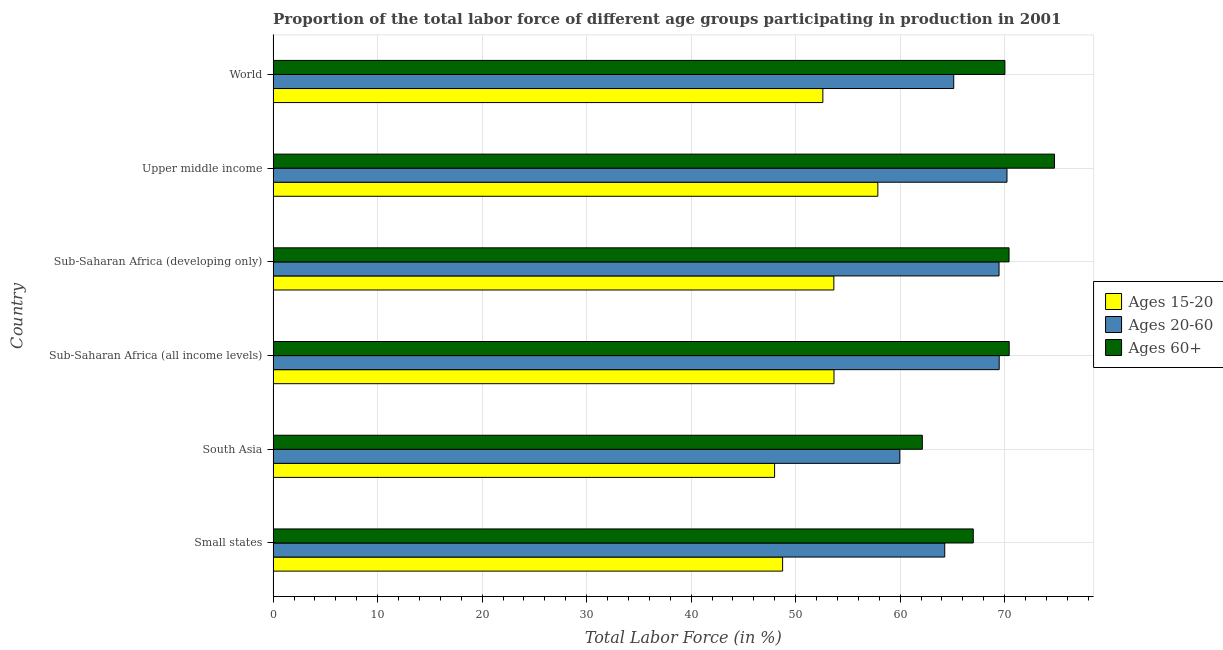How many different coloured bars are there?
Make the answer very short. 3. Are the number of bars per tick equal to the number of legend labels?
Ensure brevity in your answer.  Yes. What is the label of the 3rd group of bars from the top?
Offer a terse response. Sub-Saharan Africa (developing only). In how many cases, is the number of bars for a given country not equal to the number of legend labels?
Provide a succinct answer. 0. What is the percentage of labor force within the age group 20-60 in South Asia?
Give a very brief answer. 59.97. Across all countries, what is the maximum percentage of labor force within the age group 20-60?
Give a very brief answer. 70.22. Across all countries, what is the minimum percentage of labor force within the age group 20-60?
Offer a very short reply. 59.97. In which country was the percentage of labor force within the age group 20-60 maximum?
Your answer should be very brief. Upper middle income. In which country was the percentage of labor force within the age group 15-20 minimum?
Ensure brevity in your answer.  South Asia. What is the total percentage of labor force within the age group 15-20 in the graph?
Make the answer very short. 314.54. What is the difference between the percentage of labor force within the age group 15-20 in Small states and that in World?
Offer a terse response. -3.85. What is the difference between the percentage of labor force within the age group 15-20 in World and the percentage of labor force above age 60 in Sub-Saharan Africa (developing only)?
Provide a short and direct response. -17.82. What is the average percentage of labor force within the age group 15-20 per country?
Your answer should be very brief. 52.42. What is the difference between the percentage of labor force above age 60 and percentage of labor force within the age group 20-60 in Small states?
Your answer should be very brief. 2.73. What is the ratio of the percentage of labor force within the age group 15-20 in Upper middle income to that in World?
Provide a succinct answer. 1.1. Is the percentage of labor force above age 60 in South Asia less than that in Upper middle income?
Give a very brief answer. Yes. What is the difference between the highest and the second highest percentage of labor force within the age group 20-60?
Offer a terse response. 0.74. What is the difference between the highest and the lowest percentage of labor force within the age group 20-60?
Keep it short and to the point. 10.25. In how many countries, is the percentage of labor force within the age group 20-60 greater than the average percentage of labor force within the age group 20-60 taken over all countries?
Your answer should be compact. 3. What does the 2nd bar from the top in South Asia represents?
Provide a succinct answer. Ages 20-60. What does the 2nd bar from the bottom in South Asia represents?
Provide a succinct answer. Ages 20-60. How many bars are there?
Your response must be concise. 18. How many countries are there in the graph?
Provide a short and direct response. 6. What is the difference between two consecutive major ticks on the X-axis?
Your response must be concise. 10. Are the values on the major ticks of X-axis written in scientific E-notation?
Give a very brief answer. No. Does the graph contain any zero values?
Make the answer very short. No. Where does the legend appear in the graph?
Ensure brevity in your answer.  Center right. How many legend labels are there?
Give a very brief answer. 3. How are the legend labels stacked?
Keep it short and to the point. Vertical. What is the title of the graph?
Provide a short and direct response. Proportion of the total labor force of different age groups participating in production in 2001. Does "Primary" appear as one of the legend labels in the graph?
Ensure brevity in your answer.  No. What is the label or title of the X-axis?
Your answer should be very brief. Total Labor Force (in %). What is the label or title of the Y-axis?
Keep it short and to the point. Country. What is the Total Labor Force (in %) of Ages 15-20 in Small states?
Offer a terse response. 48.75. What is the Total Labor Force (in %) in Ages 20-60 in Small states?
Offer a terse response. 64.27. What is the Total Labor Force (in %) in Ages 60+ in Small states?
Your answer should be very brief. 67. What is the Total Labor Force (in %) in Ages 15-20 in South Asia?
Give a very brief answer. 47.99. What is the Total Labor Force (in %) of Ages 20-60 in South Asia?
Keep it short and to the point. 59.97. What is the Total Labor Force (in %) of Ages 60+ in South Asia?
Provide a short and direct response. 62.12. What is the Total Labor Force (in %) of Ages 15-20 in Sub-Saharan Africa (all income levels)?
Provide a succinct answer. 53.67. What is the Total Labor Force (in %) in Ages 20-60 in Sub-Saharan Africa (all income levels)?
Provide a short and direct response. 69.48. What is the Total Labor Force (in %) in Ages 60+ in Sub-Saharan Africa (all income levels)?
Give a very brief answer. 70.44. What is the Total Labor Force (in %) of Ages 15-20 in Sub-Saharan Africa (developing only)?
Ensure brevity in your answer.  53.66. What is the Total Labor Force (in %) of Ages 20-60 in Sub-Saharan Africa (developing only)?
Your answer should be very brief. 69.46. What is the Total Labor Force (in %) in Ages 60+ in Sub-Saharan Africa (developing only)?
Ensure brevity in your answer.  70.42. What is the Total Labor Force (in %) in Ages 15-20 in Upper middle income?
Provide a short and direct response. 57.87. What is the Total Labor Force (in %) in Ages 20-60 in Upper middle income?
Keep it short and to the point. 70.22. What is the Total Labor Force (in %) in Ages 60+ in Upper middle income?
Your answer should be compact. 74.77. What is the Total Labor Force (in %) in Ages 15-20 in World?
Offer a very short reply. 52.6. What is the Total Labor Force (in %) of Ages 20-60 in World?
Make the answer very short. 65.13. What is the Total Labor Force (in %) in Ages 60+ in World?
Your answer should be compact. 70.02. Across all countries, what is the maximum Total Labor Force (in %) in Ages 15-20?
Keep it short and to the point. 57.87. Across all countries, what is the maximum Total Labor Force (in %) in Ages 20-60?
Provide a succinct answer. 70.22. Across all countries, what is the maximum Total Labor Force (in %) in Ages 60+?
Keep it short and to the point. 74.77. Across all countries, what is the minimum Total Labor Force (in %) of Ages 15-20?
Give a very brief answer. 47.99. Across all countries, what is the minimum Total Labor Force (in %) of Ages 20-60?
Provide a succinct answer. 59.97. Across all countries, what is the minimum Total Labor Force (in %) of Ages 60+?
Keep it short and to the point. 62.12. What is the total Total Labor Force (in %) in Ages 15-20 in the graph?
Offer a very short reply. 314.54. What is the total Total Labor Force (in %) in Ages 20-60 in the graph?
Give a very brief answer. 398.53. What is the total Total Labor Force (in %) in Ages 60+ in the graph?
Keep it short and to the point. 414.77. What is the difference between the Total Labor Force (in %) of Ages 15-20 in Small states and that in South Asia?
Your answer should be compact. 0.77. What is the difference between the Total Labor Force (in %) of Ages 20-60 in Small states and that in South Asia?
Provide a succinct answer. 4.3. What is the difference between the Total Labor Force (in %) of Ages 60+ in Small states and that in South Asia?
Ensure brevity in your answer.  4.88. What is the difference between the Total Labor Force (in %) of Ages 15-20 in Small states and that in Sub-Saharan Africa (all income levels)?
Your answer should be compact. -4.92. What is the difference between the Total Labor Force (in %) of Ages 20-60 in Small states and that in Sub-Saharan Africa (all income levels)?
Your answer should be compact. -5.21. What is the difference between the Total Labor Force (in %) in Ages 60+ in Small states and that in Sub-Saharan Africa (all income levels)?
Offer a very short reply. -3.44. What is the difference between the Total Labor Force (in %) in Ages 15-20 in Small states and that in Sub-Saharan Africa (developing only)?
Offer a very short reply. -4.9. What is the difference between the Total Labor Force (in %) of Ages 20-60 in Small states and that in Sub-Saharan Africa (developing only)?
Provide a succinct answer. -5.2. What is the difference between the Total Labor Force (in %) of Ages 60+ in Small states and that in Sub-Saharan Africa (developing only)?
Provide a short and direct response. -3.42. What is the difference between the Total Labor Force (in %) in Ages 15-20 in Small states and that in Upper middle income?
Give a very brief answer. -9.11. What is the difference between the Total Labor Force (in %) of Ages 20-60 in Small states and that in Upper middle income?
Give a very brief answer. -5.96. What is the difference between the Total Labor Force (in %) of Ages 60+ in Small states and that in Upper middle income?
Your response must be concise. -7.77. What is the difference between the Total Labor Force (in %) of Ages 15-20 in Small states and that in World?
Your answer should be compact. -3.85. What is the difference between the Total Labor Force (in %) of Ages 20-60 in Small states and that in World?
Ensure brevity in your answer.  -0.86. What is the difference between the Total Labor Force (in %) of Ages 60+ in Small states and that in World?
Your answer should be compact. -3.03. What is the difference between the Total Labor Force (in %) of Ages 15-20 in South Asia and that in Sub-Saharan Africa (all income levels)?
Give a very brief answer. -5.68. What is the difference between the Total Labor Force (in %) of Ages 20-60 in South Asia and that in Sub-Saharan Africa (all income levels)?
Your answer should be compact. -9.51. What is the difference between the Total Labor Force (in %) in Ages 60+ in South Asia and that in Sub-Saharan Africa (all income levels)?
Offer a very short reply. -8.31. What is the difference between the Total Labor Force (in %) in Ages 15-20 in South Asia and that in Sub-Saharan Africa (developing only)?
Provide a succinct answer. -5.67. What is the difference between the Total Labor Force (in %) in Ages 20-60 in South Asia and that in Sub-Saharan Africa (developing only)?
Your answer should be compact. -9.49. What is the difference between the Total Labor Force (in %) in Ages 60+ in South Asia and that in Sub-Saharan Africa (developing only)?
Offer a very short reply. -8.3. What is the difference between the Total Labor Force (in %) in Ages 15-20 in South Asia and that in Upper middle income?
Your answer should be very brief. -9.88. What is the difference between the Total Labor Force (in %) in Ages 20-60 in South Asia and that in Upper middle income?
Give a very brief answer. -10.25. What is the difference between the Total Labor Force (in %) of Ages 60+ in South Asia and that in Upper middle income?
Offer a terse response. -12.65. What is the difference between the Total Labor Force (in %) in Ages 15-20 in South Asia and that in World?
Keep it short and to the point. -4.62. What is the difference between the Total Labor Force (in %) in Ages 20-60 in South Asia and that in World?
Offer a very short reply. -5.16. What is the difference between the Total Labor Force (in %) of Ages 60+ in South Asia and that in World?
Offer a terse response. -7.9. What is the difference between the Total Labor Force (in %) of Ages 15-20 in Sub-Saharan Africa (all income levels) and that in Sub-Saharan Africa (developing only)?
Keep it short and to the point. 0.01. What is the difference between the Total Labor Force (in %) in Ages 20-60 in Sub-Saharan Africa (all income levels) and that in Sub-Saharan Africa (developing only)?
Make the answer very short. 0.01. What is the difference between the Total Labor Force (in %) in Ages 60+ in Sub-Saharan Africa (all income levels) and that in Sub-Saharan Africa (developing only)?
Offer a terse response. 0.02. What is the difference between the Total Labor Force (in %) of Ages 15-20 in Sub-Saharan Africa (all income levels) and that in Upper middle income?
Provide a short and direct response. -4.2. What is the difference between the Total Labor Force (in %) of Ages 20-60 in Sub-Saharan Africa (all income levels) and that in Upper middle income?
Give a very brief answer. -0.75. What is the difference between the Total Labor Force (in %) of Ages 60+ in Sub-Saharan Africa (all income levels) and that in Upper middle income?
Your answer should be very brief. -4.33. What is the difference between the Total Labor Force (in %) in Ages 15-20 in Sub-Saharan Africa (all income levels) and that in World?
Offer a very short reply. 1.07. What is the difference between the Total Labor Force (in %) of Ages 20-60 in Sub-Saharan Africa (all income levels) and that in World?
Make the answer very short. 4.35. What is the difference between the Total Labor Force (in %) in Ages 60+ in Sub-Saharan Africa (all income levels) and that in World?
Give a very brief answer. 0.41. What is the difference between the Total Labor Force (in %) in Ages 15-20 in Sub-Saharan Africa (developing only) and that in Upper middle income?
Give a very brief answer. -4.21. What is the difference between the Total Labor Force (in %) in Ages 20-60 in Sub-Saharan Africa (developing only) and that in Upper middle income?
Keep it short and to the point. -0.76. What is the difference between the Total Labor Force (in %) in Ages 60+ in Sub-Saharan Africa (developing only) and that in Upper middle income?
Make the answer very short. -4.35. What is the difference between the Total Labor Force (in %) in Ages 15-20 in Sub-Saharan Africa (developing only) and that in World?
Ensure brevity in your answer.  1.05. What is the difference between the Total Labor Force (in %) in Ages 20-60 in Sub-Saharan Africa (developing only) and that in World?
Offer a very short reply. 4.34. What is the difference between the Total Labor Force (in %) in Ages 60+ in Sub-Saharan Africa (developing only) and that in World?
Give a very brief answer. 0.4. What is the difference between the Total Labor Force (in %) in Ages 15-20 in Upper middle income and that in World?
Offer a terse response. 5.26. What is the difference between the Total Labor Force (in %) in Ages 20-60 in Upper middle income and that in World?
Offer a terse response. 5.1. What is the difference between the Total Labor Force (in %) in Ages 60+ in Upper middle income and that in World?
Offer a terse response. 4.74. What is the difference between the Total Labor Force (in %) in Ages 15-20 in Small states and the Total Labor Force (in %) in Ages 20-60 in South Asia?
Keep it short and to the point. -11.22. What is the difference between the Total Labor Force (in %) in Ages 15-20 in Small states and the Total Labor Force (in %) in Ages 60+ in South Asia?
Give a very brief answer. -13.37. What is the difference between the Total Labor Force (in %) of Ages 20-60 in Small states and the Total Labor Force (in %) of Ages 60+ in South Asia?
Provide a succinct answer. 2.14. What is the difference between the Total Labor Force (in %) of Ages 15-20 in Small states and the Total Labor Force (in %) of Ages 20-60 in Sub-Saharan Africa (all income levels)?
Ensure brevity in your answer.  -20.72. What is the difference between the Total Labor Force (in %) of Ages 15-20 in Small states and the Total Labor Force (in %) of Ages 60+ in Sub-Saharan Africa (all income levels)?
Offer a terse response. -21.68. What is the difference between the Total Labor Force (in %) in Ages 20-60 in Small states and the Total Labor Force (in %) in Ages 60+ in Sub-Saharan Africa (all income levels)?
Your answer should be very brief. -6.17. What is the difference between the Total Labor Force (in %) of Ages 15-20 in Small states and the Total Labor Force (in %) of Ages 20-60 in Sub-Saharan Africa (developing only)?
Provide a succinct answer. -20.71. What is the difference between the Total Labor Force (in %) of Ages 15-20 in Small states and the Total Labor Force (in %) of Ages 60+ in Sub-Saharan Africa (developing only)?
Give a very brief answer. -21.67. What is the difference between the Total Labor Force (in %) in Ages 20-60 in Small states and the Total Labor Force (in %) in Ages 60+ in Sub-Saharan Africa (developing only)?
Offer a very short reply. -6.15. What is the difference between the Total Labor Force (in %) in Ages 15-20 in Small states and the Total Labor Force (in %) in Ages 20-60 in Upper middle income?
Your answer should be compact. -21.47. What is the difference between the Total Labor Force (in %) of Ages 15-20 in Small states and the Total Labor Force (in %) of Ages 60+ in Upper middle income?
Offer a terse response. -26.02. What is the difference between the Total Labor Force (in %) of Ages 20-60 in Small states and the Total Labor Force (in %) of Ages 60+ in Upper middle income?
Your response must be concise. -10.5. What is the difference between the Total Labor Force (in %) in Ages 15-20 in Small states and the Total Labor Force (in %) in Ages 20-60 in World?
Your response must be concise. -16.37. What is the difference between the Total Labor Force (in %) in Ages 15-20 in Small states and the Total Labor Force (in %) in Ages 60+ in World?
Your response must be concise. -21.27. What is the difference between the Total Labor Force (in %) in Ages 20-60 in Small states and the Total Labor Force (in %) in Ages 60+ in World?
Give a very brief answer. -5.76. What is the difference between the Total Labor Force (in %) of Ages 15-20 in South Asia and the Total Labor Force (in %) of Ages 20-60 in Sub-Saharan Africa (all income levels)?
Make the answer very short. -21.49. What is the difference between the Total Labor Force (in %) in Ages 15-20 in South Asia and the Total Labor Force (in %) in Ages 60+ in Sub-Saharan Africa (all income levels)?
Provide a short and direct response. -22.45. What is the difference between the Total Labor Force (in %) in Ages 20-60 in South Asia and the Total Labor Force (in %) in Ages 60+ in Sub-Saharan Africa (all income levels)?
Provide a short and direct response. -10.47. What is the difference between the Total Labor Force (in %) in Ages 15-20 in South Asia and the Total Labor Force (in %) in Ages 20-60 in Sub-Saharan Africa (developing only)?
Ensure brevity in your answer.  -21.48. What is the difference between the Total Labor Force (in %) in Ages 15-20 in South Asia and the Total Labor Force (in %) in Ages 60+ in Sub-Saharan Africa (developing only)?
Offer a terse response. -22.43. What is the difference between the Total Labor Force (in %) in Ages 20-60 in South Asia and the Total Labor Force (in %) in Ages 60+ in Sub-Saharan Africa (developing only)?
Give a very brief answer. -10.45. What is the difference between the Total Labor Force (in %) of Ages 15-20 in South Asia and the Total Labor Force (in %) of Ages 20-60 in Upper middle income?
Provide a succinct answer. -22.24. What is the difference between the Total Labor Force (in %) in Ages 15-20 in South Asia and the Total Labor Force (in %) in Ages 60+ in Upper middle income?
Make the answer very short. -26.78. What is the difference between the Total Labor Force (in %) of Ages 20-60 in South Asia and the Total Labor Force (in %) of Ages 60+ in Upper middle income?
Provide a short and direct response. -14.8. What is the difference between the Total Labor Force (in %) in Ages 15-20 in South Asia and the Total Labor Force (in %) in Ages 20-60 in World?
Your answer should be very brief. -17.14. What is the difference between the Total Labor Force (in %) of Ages 15-20 in South Asia and the Total Labor Force (in %) of Ages 60+ in World?
Ensure brevity in your answer.  -22.04. What is the difference between the Total Labor Force (in %) in Ages 20-60 in South Asia and the Total Labor Force (in %) in Ages 60+ in World?
Your answer should be compact. -10.05. What is the difference between the Total Labor Force (in %) of Ages 15-20 in Sub-Saharan Africa (all income levels) and the Total Labor Force (in %) of Ages 20-60 in Sub-Saharan Africa (developing only)?
Keep it short and to the point. -15.79. What is the difference between the Total Labor Force (in %) of Ages 15-20 in Sub-Saharan Africa (all income levels) and the Total Labor Force (in %) of Ages 60+ in Sub-Saharan Africa (developing only)?
Provide a short and direct response. -16.75. What is the difference between the Total Labor Force (in %) in Ages 20-60 in Sub-Saharan Africa (all income levels) and the Total Labor Force (in %) in Ages 60+ in Sub-Saharan Africa (developing only)?
Give a very brief answer. -0.94. What is the difference between the Total Labor Force (in %) in Ages 15-20 in Sub-Saharan Africa (all income levels) and the Total Labor Force (in %) in Ages 20-60 in Upper middle income?
Your answer should be very brief. -16.55. What is the difference between the Total Labor Force (in %) of Ages 15-20 in Sub-Saharan Africa (all income levels) and the Total Labor Force (in %) of Ages 60+ in Upper middle income?
Offer a very short reply. -21.1. What is the difference between the Total Labor Force (in %) of Ages 20-60 in Sub-Saharan Africa (all income levels) and the Total Labor Force (in %) of Ages 60+ in Upper middle income?
Ensure brevity in your answer.  -5.29. What is the difference between the Total Labor Force (in %) in Ages 15-20 in Sub-Saharan Africa (all income levels) and the Total Labor Force (in %) in Ages 20-60 in World?
Your answer should be compact. -11.46. What is the difference between the Total Labor Force (in %) in Ages 15-20 in Sub-Saharan Africa (all income levels) and the Total Labor Force (in %) in Ages 60+ in World?
Ensure brevity in your answer.  -16.35. What is the difference between the Total Labor Force (in %) of Ages 20-60 in Sub-Saharan Africa (all income levels) and the Total Labor Force (in %) of Ages 60+ in World?
Give a very brief answer. -0.55. What is the difference between the Total Labor Force (in %) of Ages 15-20 in Sub-Saharan Africa (developing only) and the Total Labor Force (in %) of Ages 20-60 in Upper middle income?
Provide a succinct answer. -16.57. What is the difference between the Total Labor Force (in %) in Ages 15-20 in Sub-Saharan Africa (developing only) and the Total Labor Force (in %) in Ages 60+ in Upper middle income?
Provide a succinct answer. -21.11. What is the difference between the Total Labor Force (in %) in Ages 20-60 in Sub-Saharan Africa (developing only) and the Total Labor Force (in %) in Ages 60+ in Upper middle income?
Your response must be concise. -5.31. What is the difference between the Total Labor Force (in %) of Ages 15-20 in Sub-Saharan Africa (developing only) and the Total Labor Force (in %) of Ages 20-60 in World?
Give a very brief answer. -11.47. What is the difference between the Total Labor Force (in %) of Ages 15-20 in Sub-Saharan Africa (developing only) and the Total Labor Force (in %) of Ages 60+ in World?
Provide a succinct answer. -16.37. What is the difference between the Total Labor Force (in %) of Ages 20-60 in Sub-Saharan Africa (developing only) and the Total Labor Force (in %) of Ages 60+ in World?
Your answer should be very brief. -0.56. What is the difference between the Total Labor Force (in %) of Ages 15-20 in Upper middle income and the Total Labor Force (in %) of Ages 20-60 in World?
Provide a succinct answer. -7.26. What is the difference between the Total Labor Force (in %) of Ages 15-20 in Upper middle income and the Total Labor Force (in %) of Ages 60+ in World?
Provide a succinct answer. -12.16. What is the difference between the Total Labor Force (in %) of Ages 20-60 in Upper middle income and the Total Labor Force (in %) of Ages 60+ in World?
Offer a terse response. 0.2. What is the average Total Labor Force (in %) of Ages 15-20 per country?
Keep it short and to the point. 52.42. What is the average Total Labor Force (in %) in Ages 20-60 per country?
Provide a succinct answer. 66.42. What is the average Total Labor Force (in %) of Ages 60+ per country?
Give a very brief answer. 69.13. What is the difference between the Total Labor Force (in %) of Ages 15-20 and Total Labor Force (in %) of Ages 20-60 in Small states?
Offer a terse response. -15.51. What is the difference between the Total Labor Force (in %) in Ages 15-20 and Total Labor Force (in %) in Ages 60+ in Small states?
Offer a very short reply. -18.24. What is the difference between the Total Labor Force (in %) of Ages 20-60 and Total Labor Force (in %) of Ages 60+ in Small states?
Make the answer very short. -2.73. What is the difference between the Total Labor Force (in %) in Ages 15-20 and Total Labor Force (in %) in Ages 20-60 in South Asia?
Make the answer very short. -11.98. What is the difference between the Total Labor Force (in %) in Ages 15-20 and Total Labor Force (in %) in Ages 60+ in South Asia?
Your response must be concise. -14.14. What is the difference between the Total Labor Force (in %) of Ages 20-60 and Total Labor Force (in %) of Ages 60+ in South Asia?
Offer a very short reply. -2.15. What is the difference between the Total Labor Force (in %) of Ages 15-20 and Total Labor Force (in %) of Ages 20-60 in Sub-Saharan Africa (all income levels)?
Your answer should be compact. -15.81. What is the difference between the Total Labor Force (in %) of Ages 15-20 and Total Labor Force (in %) of Ages 60+ in Sub-Saharan Africa (all income levels)?
Your answer should be very brief. -16.77. What is the difference between the Total Labor Force (in %) in Ages 20-60 and Total Labor Force (in %) in Ages 60+ in Sub-Saharan Africa (all income levels)?
Your answer should be very brief. -0.96. What is the difference between the Total Labor Force (in %) of Ages 15-20 and Total Labor Force (in %) of Ages 20-60 in Sub-Saharan Africa (developing only)?
Your answer should be very brief. -15.81. What is the difference between the Total Labor Force (in %) of Ages 15-20 and Total Labor Force (in %) of Ages 60+ in Sub-Saharan Africa (developing only)?
Provide a short and direct response. -16.76. What is the difference between the Total Labor Force (in %) in Ages 20-60 and Total Labor Force (in %) in Ages 60+ in Sub-Saharan Africa (developing only)?
Offer a very short reply. -0.96. What is the difference between the Total Labor Force (in %) in Ages 15-20 and Total Labor Force (in %) in Ages 20-60 in Upper middle income?
Your response must be concise. -12.36. What is the difference between the Total Labor Force (in %) in Ages 15-20 and Total Labor Force (in %) in Ages 60+ in Upper middle income?
Give a very brief answer. -16.9. What is the difference between the Total Labor Force (in %) of Ages 20-60 and Total Labor Force (in %) of Ages 60+ in Upper middle income?
Give a very brief answer. -4.55. What is the difference between the Total Labor Force (in %) in Ages 15-20 and Total Labor Force (in %) in Ages 20-60 in World?
Offer a very short reply. -12.52. What is the difference between the Total Labor Force (in %) of Ages 15-20 and Total Labor Force (in %) of Ages 60+ in World?
Make the answer very short. -17.42. What is the difference between the Total Labor Force (in %) in Ages 20-60 and Total Labor Force (in %) in Ages 60+ in World?
Keep it short and to the point. -4.9. What is the ratio of the Total Labor Force (in %) of Ages 20-60 in Small states to that in South Asia?
Your answer should be compact. 1.07. What is the ratio of the Total Labor Force (in %) of Ages 60+ in Small states to that in South Asia?
Keep it short and to the point. 1.08. What is the ratio of the Total Labor Force (in %) of Ages 15-20 in Small states to that in Sub-Saharan Africa (all income levels)?
Offer a terse response. 0.91. What is the ratio of the Total Labor Force (in %) of Ages 20-60 in Small states to that in Sub-Saharan Africa (all income levels)?
Your answer should be compact. 0.93. What is the ratio of the Total Labor Force (in %) in Ages 60+ in Small states to that in Sub-Saharan Africa (all income levels)?
Your response must be concise. 0.95. What is the ratio of the Total Labor Force (in %) in Ages 15-20 in Small states to that in Sub-Saharan Africa (developing only)?
Keep it short and to the point. 0.91. What is the ratio of the Total Labor Force (in %) of Ages 20-60 in Small states to that in Sub-Saharan Africa (developing only)?
Provide a succinct answer. 0.93. What is the ratio of the Total Labor Force (in %) of Ages 60+ in Small states to that in Sub-Saharan Africa (developing only)?
Your answer should be compact. 0.95. What is the ratio of the Total Labor Force (in %) of Ages 15-20 in Small states to that in Upper middle income?
Your answer should be very brief. 0.84. What is the ratio of the Total Labor Force (in %) of Ages 20-60 in Small states to that in Upper middle income?
Give a very brief answer. 0.92. What is the ratio of the Total Labor Force (in %) in Ages 60+ in Small states to that in Upper middle income?
Provide a short and direct response. 0.9. What is the ratio of the Total Labor Force (in %) in Ages 15-20 in Small states to that in World?
Provide a succinct answer. 0.93. What is the ratio of the Total Labor Force (in %) of Ages 60+ in Small states to that in World?
Keep it short and to the point. 0.96. What is the ratio of the Total Labor Force (in %) of Ages 15-20 in South Asia to that in Sub-Saharan Africa (all income levels)?
Your answer should be compact. 0.89. What is the ratio of the Total Labor Force (in %) in Ages 20-60 in South Asia to that in Sub-Saharan Africa (all income levels)?
Make the answer very short. 0.86. What is the ratio of the Total Labor Force (in %) of Ages 60+ in South Asia to that in Sub-Saharan Africa (all income levels)?
Provide a succinct answer. 0.88. What is the ratio of the Total Labor Force (in %) in Ages 15-20 in South Asia to that in Sub-Saharan Africa (developing only)?
Keep it short and to the point. 0.89. What is the ratio of the Total Labor Force (in %) of Ages 20-60 in South Asia to that in Sub-Saharan Africa (developing only)?
Provide a succinct answer. 0.86. What is the ratio of the Total Labor Force (in %) in Ages 60+ in South Asia to that in Sub-Saharan Africa (developing only)?
Offer a very short reply. 0.88. What is the ratio of the Total Labor Force (in %) in Ages 15-20 in South Asia to that in Upper middle income?
Provide a short and direct response. 0.83. What is the ratio of the Total Labor Force (in %) in Ages 20-60 in South Asia to that in Upper middle income?
Make the answer very short. 0.85. What is the ratio of the Total Labor Force (in %) of Ages 60+ in South Asia to that in Upper middle income?
Your answer should be very brief. 0.83. What is the ratio of the Total Labor Force (in %) in Ages 15-20 in South Asia to that in World?
Ensure brevity in your answer.  0.91. What is the ratio of the Total Labor Force (in %) in Ages 20-60 in South Asia to that in World?
Your response must be concise. 0.92. What is the ratio of the Total Labor Force (in %) of Ages 60+ in South Asia to that in World?
Your answer should be compact. 0.89. What is the ratio of the Total Labor Force (in %) in Ages 60+ in Sub-Saharan Africa (all income levels) to that in Sub-Saharan Africa (developing only)?
Ensure brevity in your answer.  1. What is the ratio of the Total Labor Force (in %) of Ages 15-20 in Sub-Saharan Africa (all income levels) to that in Upper middle income?
Offer a very short reply. 0.93. What is the ratio of the Total Labor Force (in %) in Ages 60+ in Sub-Saharan Africa (all income levels) to that in Upper middle income?
Ensure brevity in your answer.  0.94. What is the ratio of the Total Labor Force (in %) in Ages 15-20 in Sub-Saharan Africa (all income levels) to that in World?
Make the answer very short. 1.02. What is the ratio of the Total Labor Force (in %) of Ages 20-60 in Sub-Saharan Africa (all income levels) to that in World?
Make the answer very short. 1.07. What is the ratio of the Total Labor Force (in %) in Ages 60+ in Sub-Saharan Africa (all income levels) to that in World?
Offer a very short reply. 1.01. What is the ratio of the Total Labor Force (in %) of Ages 15-20 in Sub-Saharan Africa (developing only) to that in Upper middle income?
Offer a terse response. 0.93. What is the ratio of the Total Labor Force (in %) in Ages 20-60 in Sub-Saharan Africa (developing only) to that in Upper middle income?
Your answer should be compact. 0.99. What is the ratio of the Total Labor Force (in %) in Ages 60+ in Sub-Saharan Africa (developing only) to that in Upper middle income?
Offer a very short reply. 0.94. What is the ratio of the Total Labor Force (in %) in Ages 20-60 in Sub-Saharan Africa (developing only) to that in World?
Make the answer very short. 1.07. What is the ratio of the Total Labor Force (in %) of Ages 60+ in Sub-Saharan Africa (developing only) to that in World?
Offer a very short reply. 1.01. What is the ratio of the Total Labor Force (in %) in Ages 20-60 in Upper middle income to that in World?
Provide a succinct answer. 1.08. What is the ratio of the Total Labor Force (in %) of Ages 60+ in Upper middle income to that in World?
Provide a succinct answer. 1.07. What is the difference between the highest and the second highest Total Labor Force (in %) in Ages 15-20?
Keep it short and to the point. 4.2. What is the difference between the highest and the second highest Total Labor Force (in %) of Ages 20-60?
Provide a short and direct response. 0.75. What is the difference between the highest and the second highest Total Labor Force (in %) of Ages 60+?
Your response must be concise. 4.33. What is the difference between the highest and the lowest Total Labor Force (in %) in Ages 15-20?
Your response must be concise. 9.88. What is the difference between the highest and the lowest Total Labor Force (in %) in Ages 20-60?
Offer a terse response. 10.25. What is the difference between the highest and the lowest Total Labor Force (in %) of Ages 60+?
Ensure brevity in your answer.  12.65. 